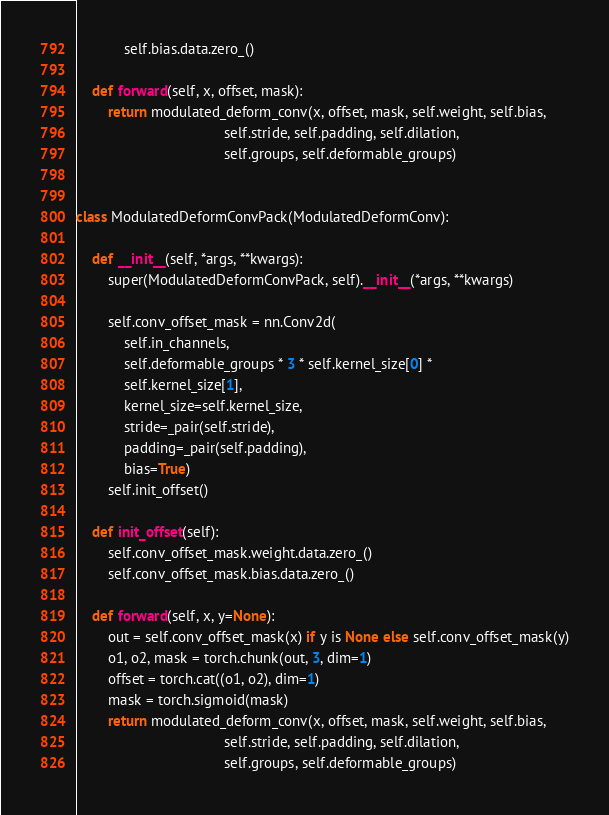Convert code to text. <code><loc_0><loc_0><loc_500><loc_500><_Python_>            self.bias.data.zero_()

    def forward(self, x, offset, mask):
        return modulated_deform_conv(x, offset, mask, self.weight, self.bias,
                                     self.stride, self.padding, self.dilation,
                                     self.groups, self.deformable_groups)


class ModulatedDeformConvPack(ModulatedDeformConv):

    def __init__(self, *args, **kwargs):
        super(ModulatedDeformConvPack, self).__init__(*args, **kwargs)

        self.conv_offset_mask = nn.Conv2d(
            self.in_channels,
            self.deformable_groups * 3 * self.kernel_size[0] *
            self.kernel_size[1],
            kernel_size=self.kernel_size,
            stride=_pair(self.stride),
            padding=_pair(self.padding),
            bias=True)
        self.init_offset()

    def init_offset(self):
        self.conv_offset_mask.weight.data.zero_()
        self.conv_offset_mask.bias.data.zero_()

    def forward(self, x, y=None):
        out = self.conv_offset_mask(x) if y is None else self.conv_offset_mask(y)
        o1, o2, mask = torch.chunk(out, 3, dim=1)
        offset = torch.cat((o1, o2), dim=1)
        mask = torch.sigmoid(mask)
        return modulated_deform_conv(x, offset, mask, self.weight, self.bias,
                                     self.stride, self.padding, self.dilation,
                                     self.groups, self.deformable_groups)
</code> 